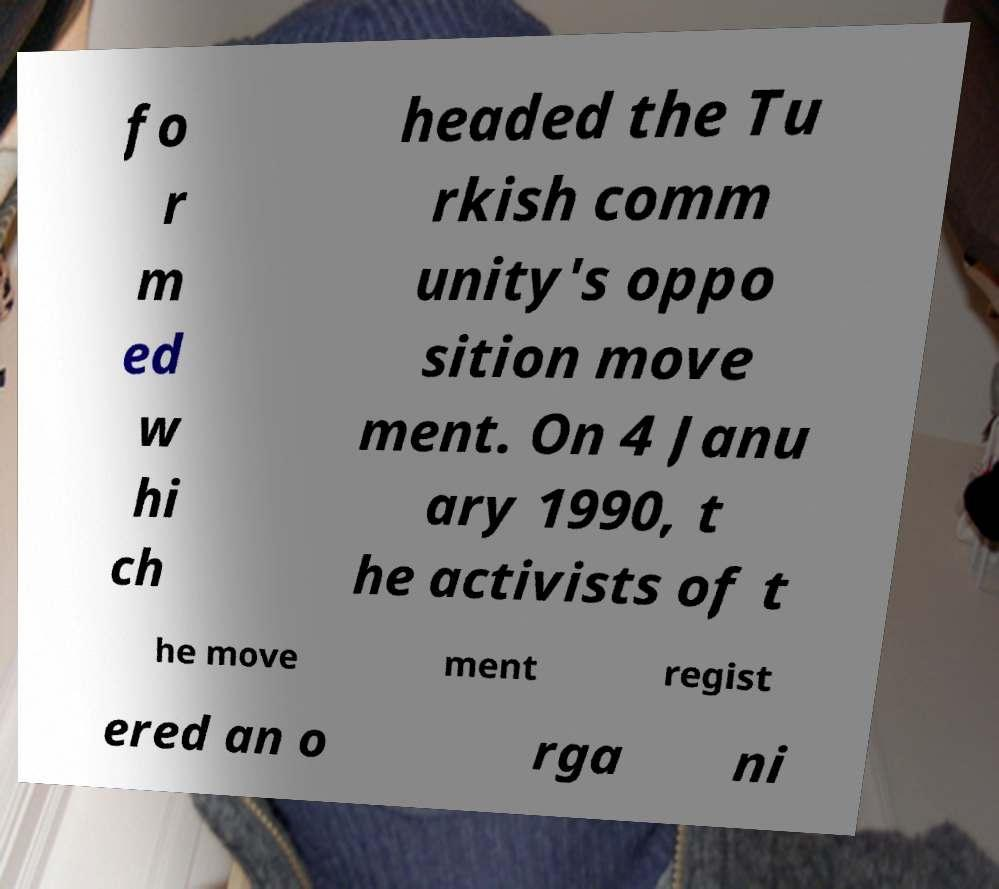Could you assist in decoding the text presented in this image and type it out clearly? fo r m ed w hi ch headed the Tu rkish comm unity's oppo sition move ment. On 4 Janu ary 1990, t he activists of t he move ment regist ered an o rga ni 